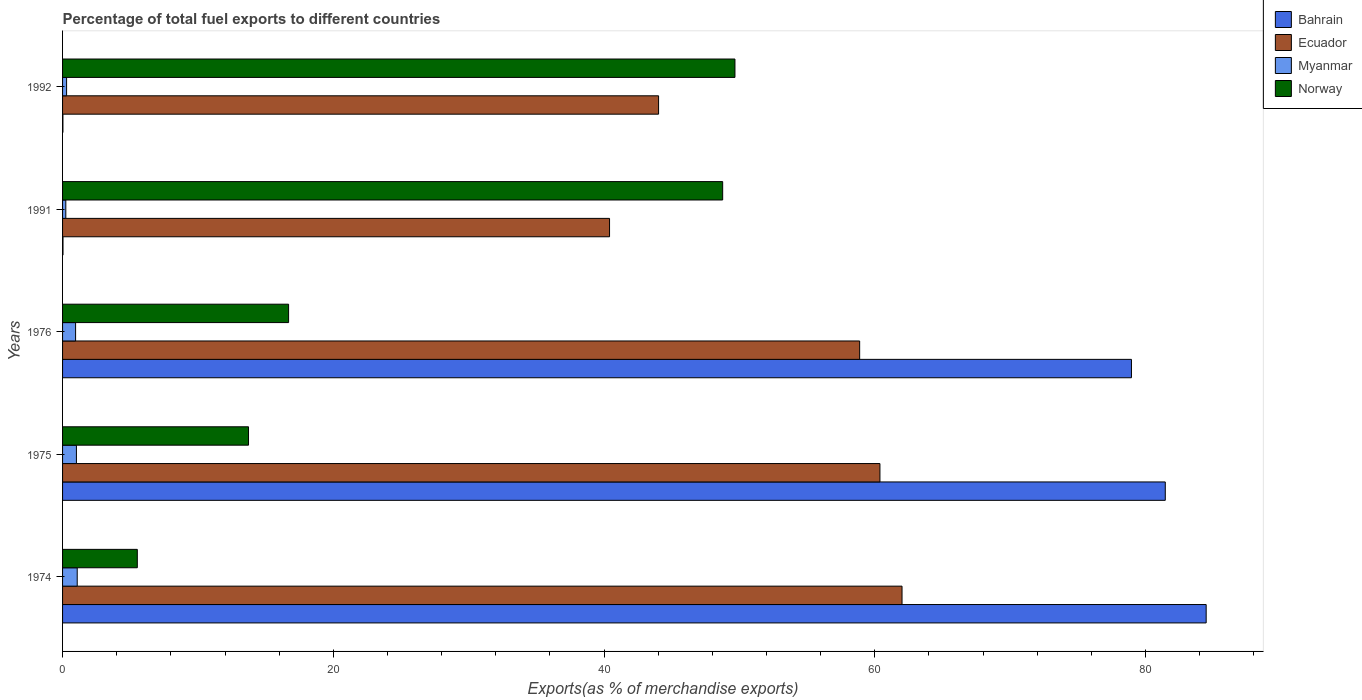How many different coloured bars are there?
Offer a very short reply. 4. How many groups of bars are there?
Provide a short and direct response. 5. Are the number of bars on each tick of the Y-axis equal?
Offer a terse response. Yes. How many bars are there on the 2nd tick from the top?
Offer a very short reply. 4. How many bars are there on the 4th tick from the bottom?
Ensure brevity in your answer.  4. In how many cases, is the number of bars for a given year not equal to the number of legend labels?
Keep it short and to the point. 0. What is the percentage of exports to different countries in Norway in 1992?
Give a very brief answer. 49.67. Across all years, what is the maximum percentage of exports to different countries in Bahrain?
Provide a succinct answer. 84.48. Across all years, what is the minimum percentage of exports to different countries in Ecuador?
Give a very brief answer. 40.41. In which year was the percentage of exports to different countries in Bahrain maximum?
Give a very brief answer. 1974. In which year was the percentage of exports to different countries in Norway minimum?
Keep it short and to the point. 1974. What is the total percentage of exports to different countries in Norway in the graph?
Your response must be concise. 134.38. What is the difference between the percentage of exports to different countries in Ecuador in 1975 and that in 1992?
Your response must be concise. 16.35. What is the difference between the percentage of exports to different countries in Myanmar in 1975 and the percentage of exports to different countries in Norway in 1974?
Give a very brief answer. -4.5. What is the average percentage of exports to different countries in Norway per year?
Ensure brevity in your answer.  26.88. In the year 1976, what is the difference between the percentage of exports to different countries in Norway and percentage of exports to different countries in Myanmar?
Give a very brief answer. 15.73. In how many years, is the percentage of exports to different countries in Ecuador greater than 24 %?
Ensure brevity in your answer.  5. What is the ratio of the percentage of exports to different countries in Myanmar in 1976 to that in 1992?
Ensure brevity in your answer.  3.24. Is the percentage of exports to different countries in Myanmar in 1975 less than that in 1991?
Your response must be concise. No. What is the difference between the highest and the second highest percentage of exports to different countries in Norway?
Your answer should be compact. 0.91. What is the difference between the highest and the lowest percentage of exports to different countries in Bahrain?
Your answer should be very brief. 84.45. In how many years, is the percentage of exports to different countries in Norway greater than the average percentage of exports to different countries in Norway taken over all years?
Offer a very short reply. 2. Is it the case that in every year, the sum of the percentage of exports to different countries in Bahrain and percentage of exports to different countries in Norway is greater than the sum of percentage of exports to different countries in Myanmar and percentage of exports to different countries in Ecuador?
Your answer should be very brief. Yes. What does the 2nd bar from the top in 1976 represents?
Provide a succinct answer. Myanmar. How many bars are there?
Ensure brevity in your answer.  20. How many years are there in the graph?
Your answer should be very brief. 5. Does the graph contain grids?
Ensure brevity in your answer.  No. What is the title of the graph?
Provide a short and direct response. Percentage of total fuel exports to different countries. Does "St. Martin (French part)" appear as one of the legend labels in the graph?
Your answer should be very brief. No. What is the label or title of the X-axis?
Provide a short and direct response. Exports(as % of merchandise exports). What is the Exports(as % of merchandise exports) of Bahrain in 1974?
Ensure brevity in your answer.  84.48. What is the Exports(as % of merchandise exports) of Ecuador in 1974?
Give a very brief answer. 62.01. What is the Exports(as % of merchandise exports) of Myanmar in 1974?
Your response must be concise. 1.08. What is the Exports(as % of merchandise exports) of Norway in 1974?
Your response must be concise. 5.52. What is the Exports(as % of merchandise exports) in Bahrain in 1975?
Your response must be concise. 81.46. What is the Exports(as % of merchandise exports) in Ecuador in 1975?
Offer a very short reply. 60.38. What is the Exports(as % of merchandise exports) of Myanmar in 1975?
Your answer should be compact. 1.02. What is the Exports(as % of merchandise exports) of Norway in 1975?
Your answer should be compact. 13.74. What is the Exports(as % of merchandise exports) in Bahrain in 1976?
Your answer should be compact. 78.96. What is the Exports(as % of merchandise exports) in Ecuador in 1976?
Give a very brief answer. 58.88. What is the Exports(as % of merchandise exports) in Myanmar in 1976?
Keep it short and to the point. 0.96. What is the Exports(as % of merchandise exports) in Norway in 1976?
Your answer should be compact. 16.7. What is the Exports(as % of merchandise exports) of Bahrain in 1991?
Offer a very short reply. 0.03. What is the Exports(as % of merchandise exports) in Ecuador in 1991?
Your answer should be very brief. 40.41. What is the Exports(as % of merchandise exports) in Myanmar in 1991?
Provide a succinct answer. 0.24. What is the Exports(as % of merchandise exports) in Norway in 1991?
Offer a very short reply. 48.76. What is the Exports(as % of merchandise exports) in Bahrain in 1992?
Offer a terse response. 0.03. What is the Exports(as % of merchandise exports) in Ecuador in 1992?
Give a very brief answer. 44.03. What is the Exports(as % of merchandise exports) in Myanmar in 1992?
Your response must be concise. 0.3. What is the Exports(as % of merchandise exports) in Norway in 1992?
Offer a very short reply. 49.67. Across all years, what is the maximum Exports(as % of merchandise exports) of Bahrain?
Provide a succinct answer. 84.48. Across all years, what is the maximum Exports(as % of merchandise exports) in Ecuador?
Make the answer very short. 62.01. Across all years, what is the maximum Exports(as % of merchandise exports) of Myanmar?
Give a very brief answer. 1.08. Across all years, what is the maximum Exports(as % of merchandise exports) of Norway?
Offer a terse response. 49.67. Across all years, what is the minimum Exports(as % of merchandise exports) of Bahrain?
Your answer should be compact. 0.03. Across all years, what is the minimum Exports(as % of merchandise exports) of Ecuador?
Ensure brevity in your answer.  40.41. Across all years, what is the minimum Exports(as % of merchandise exports) in Myanmar?
Provide a succinct answer. 0.24. Across all years, what is the minimum Exports(as % of merchandise exports) in Norway?
Offer a terse response. 5.52. What is the total Exports(as % of merchandise exports) of Bahrain in the graph?
Provide a short and direct response. 244.95. What is the total Exports(as % of merchandise exports) of Ecuador in the graph?
Ensure brevity in your answer.  265.7. What is the total Exports(as % of merchandise exports) of Myanmar in the graph?
Ensure brevity in your answer.  3.61. What is the total Exports(as % of merchandise exports) in Norway in the graph?
Offer a terse response. 134.38. What is the difference between the Exports(as % of merchandise exports) of Bahrain in 1974 and that in 1975?
Provide a succinct answer. 3.02. What is the difference between the Exports(as % of merchandise exports) in Ecuador in 1974 and that in 1975?
Keep it short and to the point. 1.63. What is the difference between the Exports(as % of merchandise exports) in Myanmar in 1974 and that in 1975?
Keep it short and to the point. 0.06. What is the difference between the Exports(as % of merchandise exports) of Norway in 1974 and that in 1975?
Your answer should be very brief. -8.21. What is the difference between the Exports(as % of merchandise exports) of Bahrain in 1974 and that in 1976?
Your answer should be compact. 5.52. What is the difference between the Exports(as % of merchandise exports) in Ecuador in 1974 and that in 1976?
Provide a succinct answer. 3.13. What is the difference between the Exports(as % of merchandise exports) of Myanmar in 1974 and that in 1976?
Your answer should be compact. 0.12. What is the difference between the Exports(as % of merchandise exports) in Norway in 1974 and that in 1976?
Give a very brief answer. -11.17. What is the difference between the Exports(as % of merchandise exports) in Bahrain in 1974 and that in 1991?
Offer a terse response. 84.44. What is the difference between the Exports(as % of merchandise exports) in Ecuador in 1974 and that in 1991?
Your answer should be compact. 21.61. What is the difference between the Exports(as % of merchandise exports) of Myanmar in 1974 and that in 1991?
Offer a very short reply. 0.84. What is the difference between the Exports(as % of merchandise exports) of Norway in 1974 and that in 1991?
Keep it short and to the point. -43.24. What is the difference between the Exports(as % of merchandise exports) of Bahrain in 1974 and that in 1992?
Offer a very short reply. 84.45. What is the difference between the Exports(as % of merchandise exports) in Ecuador in 1974 and that in 1992?
Make the answer very short. 17.98. What is the difference between the Exports(as % of merchandise exports) of Myanmar in 1974 and that in 1992?
Ensure brevity in your answer.  0.79. What is the difference between the Exports(as % of merchandise exports) of Norway in 1974 and that in 1992?
Provide a short and direct response. -44.15. What is the difference between the Exports(as % of merchandise exports) of Bahrain in 1975 and that in 1976?
Provide a short and direct response. 2.5. What is the difference between the Exports(as % of merchandise exports) of Ecuador in 1975 and that in 1976?
Provide a short and direct response. 1.5. What is the difference between the Exports(as % of merchandise exports) in Myanmar in 1975 and that in 1976?
Your response must be concise. 0.06. What is the difference between the Exports(as % of merchandise exports) of Norway in 1975 and that in 1976?
Make the answer very short. -2.96. What is the difference between the Exports(as % of merchandise exports) in Bahrain in 1975 and that in 1991?
Provide a succinct answer. 81.42. What is the difference between the Exports(as % of merchandise exports) of Ecuador in 1975 and that in 1991?
Your answer should be compact. 19.97. What is the difference between the Exports(as % of merchandise exports) of Myanmar in 1975 and that in 1991?
Ensure brevity in your answer.  0.78. What is the difference between the Exports(as % of merchandise exports) in Norway in 1975 and that in 1991?
Provide a short and direct response. -35.02. What is the difference between the Exports(as % of merchandise exports) in Bahrain in 1975 and that in 1992?
Your answer should be very brief. 81.43. What is the difference between the Exports(as % of merchandise exports) of Ecuador in 1975 and that in 1992?
Give a very brief answer. 16.35. What is the difference between the Exports(as % of merchandise exports) of Myanmar in 1975 and that in 1992?
Make the answer very short. 0.73. What is the difference between the Exports(as % of merchandise exports) of Norway in 1975 and that in 1992?
Make the answer very short. -35.93. What is the difference between the Exports(as % of merchandise exports) of Bahrain in 1976 and that in 1991?
Provide a short and direct response. 78.93. What is the difference between the Exports(as % of merchandise exports) in Ecuador in 1976 and that in 1991?
Keep it short and to the point. 18.47. What is the difference between the Exports(as % of merchandise exports) in Myanmar in 1976 and that in 1991?
Your response must be concise. 0.72. What is the difference between the Exports(as % of merchandise exports) of Norway in 1976 and that in 1991?
Provide a succinct answer. -32.06. What is the difference between the Exports(as % of merchandise exports) in Bahrain in 1976 and that in 1992?
Your answer should be compact. 78.93. What is the difference between the Exports(as % of merchandise exports) in Ecuador in 1976 and that in 1992?
Make the answer very short. 14.85. What is the difference between the Exports(as % of merchandise exports) in Myanmar in 1976 and that in 1992?
Provide a succinct answer. 0.67. What is the difference between the Exports(as % of merchandise exports) in Norway in 1976 and that in 1992?
Make the answer very short. -32.97. What is the difference between the Exports(as % of merchandise exports) in Bahrain in 1991 and that in 1992?
Your answer should be compact. 0.01. What is the difference between the Exports(as % of merchandise exports) of Ecuador in 1991 and that in 1992?
Your response must be concise. -3.62. What is the difference between the Exports(as % of merchandise exports) of Myanmar in 1991 and that in 1992?
Ensure brevity in your answer.  -0.06. What is the difference between the Exports(as % of merchandise exports) in Norway in 1991 and that in 1992?
Your answer should be very brief. -0.91. What is the difference between the Exports(as % of merchandise exports) of Bahrain in 1974 and the Exports(as % of merchandise exports) of Ecuador in 1975?
Give a very brief answer. 24.1. What is the difference between the Exports(as % of merchandise exports) in Bahrain in 1974 and the Exports(as % of merchandise exports) in Myanmar in 1975?
Provide a short and direct response. 83.45. What is the difference between the Exports(as % of merchandise exports) of Bahrain in 1974 and the Exports(as % of merchandise exports) of Norway in 1975?
Keep it short and to the point. 70.74. What is the difference between the Exports(as % of merchandise exports) in Ecuador in 1974 and the Exports(as % of merchandise exports) in Myanmar in 1975?
Give a very brief answer. 60.99. What is the difference between the Exports(as % of merchandise exports) in Ecuador in 1974 and the Exports(as % of merchandise exports) in Norway in 1975?
Ensure brevity in your answer.  48.27. What is the difference between the Exports(as % of merchandise exports) of Myanmar in 1974 and the Exports(as % of merchandise exports) of Norway in 1975?
Offer a very short reply. -12.65. What is the difference between the Exports(as % of merchandise exports) in Bahrain in 1974 and the Exports(as % of merchandise exports) in Ecuador in 1976?
Offer a very short reply. 25.6. What is the difference between the Exports(as % of merchandise exports) in Bahrain in 1974 and the Exports(as % of merchandise exports) in Myanmar in 1976?
Give a very brief answer. 83.51. What is the difference between the Exports(as % of merchandise exports) in Bahrain in 1974 and the Exports(as % of merchandise exports) in Norway in 1976?
Keep it short and to the point. 67.78. What is the difference between the Exports(as % of merchandise exports) in Ecuador in 1974 and the Exports(as % of merchandise exports) in Myanmar in 1976?
Your answer should be compact. 61.05. What is the difference between the Exports(as % of merchandise exports) in Ecuador in 1974 and the Exports(as % of merchandise exports) in Norway in 1976?
Give a very brief answer. 45.31. What is the difference between the Exports(as % of merchandise exports) of Myanmar in 1974 and the Exports(as % of merchandise exports) of Norway in 1976?
Your answer should be compact. -15.61. What is the difference between the Exports(as % of merchandise exports) of Bahrain in 1974 and the Exports(as % of merchandise exports) of Ecuador in 1991?
Keep it short and to the point. 44.07. What is the difference between the Exports(as % of merchandise exports) in Bahrain in 1974 and the Exports(as % of merchandise exports) in Myanmar in 1991?
Keep it short and to the point. 84.24. What is the difference between the Exports(as % of merchandise exports) of Bahrain in 1974 and the Exports(as % of merchandise exports) of Norway in 1991?
Offer a terse response. 35.72. What is the difference between the Exports(as % of merchandise exports) in Ecuador in 1974 and the Exports(as % of merchandise exports) in Myanmar in 1991?
Make the answer very short. 61.77. What is the difference between the Exports(as % of merchandise exports) of Ecuador in 1974 and the Exports(as % of merchandise exports) of Norway in 1991?
Your answer should be compact. 13.25. What is the difference between the Exports(as % of merchandise exports) of Myanmar in 1974 and the Exports(as % of merchandise exports) of Norway in 1991?
Make the answer very short. -47.68. What is the difference between the Exports(as % of merchandise exports) in Bahrain in 1974 and the Exports(as % of merchandise exports) in Ecuador in 1992?
Provide a short and direct response. 40.45. What is the difference between the Exports(as % of merchandise exports) of Bahrain in 1974 and the Exports(as % of merchandise exports) of Myanmar in 1992?
Keep it short and to the point. 84.18. What is the difference between the Exports(as % of merchandise exports) in Bahrain in 1974 and the Exports(as % of merchandise exports) in Norway in 1992?
Provide a short and direct response. 34.81. What is the difference between the Exports(as % of merchandise exports) of Ecuador in 1974 and the Exports(as % of merchandise exports) of Myanmar in 1992?
Your answer should be very brief. 61.71. What is the difference between the Exports(as % of merchandise exports) of Ecuador in 1974 and the Exports(as % of merchandise exports) of Norway in 1992?
Your response must be concise. 12.34. What is the difference between the Exports(as % of merchandise exports) in Myanmar in 1974 and the Exports(as % of merchandise exports) in Norway in 1992?
Give a very brief answer. -48.59. What is the difference between the Exports(as % of merchandise exports) of Bahrain in 1975 and the Exports(as % of merchandise exports) of Ecuador in 1976?
Ensure brevity in your answer.  22.58. What is the difference between the Exports(as % of merchandise exports) in Bahrain in 1975 and the Exports(as % of merchandise exports) in Myanmar in 1976?
Make the answer very short. 80.49. What is the difference between the Exports(as % of merchandise exports) in Bahrain in 1975 and the Exports(as % of merchandise exports) in Norway in 1976?
Your response must be concise. 64.76. What is the difference between the Exports(as % of merchandise exports) in Ecuador in 1975 and the Exports(as % of merchandise exports) in Myanmar in 1976?
Your response must be concise. 59.41. What is the difference between the Exports(as % of merchandise exports) in Ecuador in 1975 and the Exports(as % of merchandise exports) in Norway in 1976?
Provide a succinct answer. 43.68. What is the difference between the Exports(as % of merchandise exports) of Myanmar in 1975 and the Exports(as % of merchandise exports) of Norway in 1976?
Keep it short and to the point. -15.67. What is the difference between the Exports(as % of merchandise exports) of Bahrain in 1975 and the Exports(as % of merchandise exports) of Ecuador in 1991?
Make the answer very short. 41.05. What is the difference between the Exports(as % of merchandise exports) of Bahrain in 1975 and the Exports(as % of merchandise exports) of Myanmar in 1991?
Give a very brief answer. 81.22. What is the difference between the Exports(as % of merchandise exports) in Bahrain in 1975 and the Exports(as % of merchandise exports) in Norway in 1991?
Make the answer very short. 32.7. What is the difference between the Exports(as % of merchandise exports) in Ecuador in 1975 and the Exports(as % of merchandise exports) in Myanmar in 1991?
Offer a very short reply. 60.14. What is the difference between the Exports(as % of merchandise exports) in Ecuador in 1975 and the Exports(as % of merchandise exports) in Norway in 1991?
Keep it short and to the point. 11.62. What is the difference between the Exports(as % of merchandise exports) in Myanmar in 1975 and the Exports(as % of merchandise exports) in Norway in 1991?
Your response must be concise. -47.74. What is the difference between the Exports(as % of merchandise exports) in Bahrain in 1975 and the Exports(as % of merchandise exports) in Ecuador in 1992?
Offer a very short reply. 37.43. What is the difference between the Exports(as % of merchandise exports) of Bahrain in 1975 and the Exports(as % of merchandise exports) of Myanmar in 1992?
Give a very brief answer. 81.16. What is the difference between the Exports(as % of merchandise exports) of Bahrain in 1975 and the Exports(as % of merchandise exports) of Norway in 1992?
Your answer should be very brief. 31.79. What is the difference between the Exports(as % of merchandise exports) in Ecuador in 1975 and the Exports(as % of merchandise exports) in Myanmar in 1992?
Your answer should be compact. 60.08. What is the difference between the Exports(as % of merchandise exports) of Ecuador in 1975 and the Exports(as % of merchandise exports) of Norway in 1992?
Give a very brief answer. 10.71. What is the difference between the Exports(as % of merchandise exports) in Myanmar in 1975 and the Exports(as % of merchandise exports) in Norway in 1992?
Offer a terse response. -48.65. What is the difference between the Exports(as % of merchandise exports) in Bahrain in 1976 and the Exports(as % of merchandise exports) in Ecuador in 1991?
Provide a short and direct response. 38.55. What is the difference between the Exports(as % of merchandise exports) of Bahrain in 1976 and the Exports(as % of merchandise exports) of Myanmar in 1991?
Your response must be concise. 78.72. What is the difference between the Exports(as % of merchandise exports) of Bahrain in 1976 and the Exports(as % of merchandise exports) of Norway in 1991?
Your response must be concise. 30.2. What is the difference between the Exports(as % of merchandise exports) of Ecuador in 1976 and the Exports(as % of merchandise exports) of Myanmar in 1991?
Ensure brevity in your answer.  58.64. What is the difference between the Exports(as % of merchandise exports) in Ecuador in 1976 and the Exports(as % of merchandise exports) in Norway in 1991?
Ensure brevity in your answer.  10.12. What is the difference between the Exports(as % of merchandise exports) of Myanmar in 1976 and the Exports(as % of merchandise exports) of Norway in 1991?
Your answer should be compact. -47.8. What is the difference between the Exports(as % of merchandise exports) of Bahrain in 1976 and the Exports(as % of merchandise exports) of Ecuador in 1992?
Keep it short and to the point. 34.93. What is the difference between the Exports(as % of merchandise exports) in Bahrain in 1976 and the Exports(as % of merchandise exports) in Myanmar in 1992?
Keep it short and to the point. 78.66. What is the difference between the Exports(as % of merchandise exports) of Bahrain in 1976 and the Exports(as % of merchandise exports) of Norway in 1992?
Keep it short and to the point. 29.29. What is the difference between the Exports(as % of merchandise exports) in Ecuador in 1976 and the Exports(as % of merchandise exports) in Myanmar in 1992?
Provide a short and direct response. 58.58. What is the difference between the Exports(as % of merchandise exports) in Ecuador in 1976 and the Exports(as % of merchandise exports) in Norway in 1992?
Provide a short and direct response. 9.21. What is the difference between the Exports(as % of merchandise exports) of Myanmar in 1976 and the Exports(as % of merchandise exports) of Norway in 1992?
Provide a short and direct response. -48.71. What is the difference between the Exports(as % of merchandise exports) in Bahrain in 1991 and the Exports(as % of merchandise exports) in Ecuador in 1992?
Offer a terse response. -44. What is the difference between the Exports(as % of merchandise exports) of Bahrain in 1991 and the Exports(as % of merchandise exports) of Myanmar in 1992?
Offer a very short reply. -0.27. What is the difference between the Exports(as % of merchandise exports) in Bahrain in 1991 and the Exports(as % of merchandise exports) in Norway in 1992?
Give a very brief answer. -49.64. What is the difference between the Exports(as % of merchandise exports) of Ecuador in 1991 and the Exports(as % of merchandise exports) of Myanmar in 1992?
Make the answer very short. 40.11. What is the difference between the Exports(as % of merchandise exports) in Ecuador in 1991 and the Exports(as % of merchandise exports) in Norway in 1992?
Offer a terse response. -9.26. What is the difference between the Exports(as % of merchandise exports) in Myanmar in 1991 and the Exports(as % of merchandise exports) in Norway in 1992?
Give a very brief answer. -49.43. What is the average Exports(as % of merchandise exports) of Bahrain per year?
Your response must be concise. 48.99. What is the average Exports(as % of merchandise exports) in Ecuador per year?
Provide a succinct answer. 53.14. What is the average Exports(as % of merchandise exports) of Myanmar per year?
Your response must be concise. 0.72. What is the average Exports(as % of merchandise exports) of Norway per year?
Your response must be concise. 26.88. In the year 1974, what is the difference between the Exports(as % of merchandise exports) of Bahrain and Exports(as % of merchandise exports) of Ecuador?
Offer a very short reply. 22.47. In the year 1974, what is the difference between the Exports(as % of merchandise exports) of Bahrain and Exports(as % of merchandise exports) of Myanmar?
Make the answer very short. 83.39. In the year 1974, what is the difference between the Exports(as % of merchandise exports) in Bahrain and Exports(as % of merchandise exports) in Norway?
Offer a terse response. 78.96. In the year 1974, what is the difference between the Exports(as % of merchandise exports) of Ecuador and Exports(as % of merchandise exports) of Myanmar?
Ensure brevity in your answer.  60.93. In the year 1974, what is the difference between the Exports(as % of merchandise exports) in Ecuador and Exports(as % of merchandise exports) in Norway?
Provide a short and direct response. 56.49. In the year 1974, what is the difference between the Exports(as % of merchandise exports) of Myanmar and Exports(as % of merchandise exports) of Norway?
Ensure brevity in your answer.  -4.44. In the year 1975, what is the difference between the Exports(as % of merchandise exports) of Bahrain and Exports(as % of merchandise exports) of Ecuador?
Keep it short and to the point. 21.08. In the year 1975, what is the difference between the Exports(as % of merchandise exports) in Bahrain and Exports(as % of merchandise exports) in Myanmar?
Offer a very short reply. 80.43. In the year 1975, what is the difference between the Exports(as % of merchandise exports) of Bahrain and Exports(as % of merchandise exports) of Norway?
Your response must be concise. 67.72. In the year 1975, what is the difference between the Exports(as % of merchandise exports) of Ecuador and Exports(as % of merchandise exports) of Myanmar?
Provide a short and direct response. 59.35. In the year 1975, what is the difference between the Exports(as % of merchandise exports) of Ecuador and Exports(as % of merchandise exports) of Norway?
Provide a succinct answer. 46.64. In the year 1975, what is the difference between the Exports(as % of merchandise exports) of Myanmar and Exports(as % of merchandise exports) of Norway?
Give a very brief answer. -12.71. In the year 1976, what is the difference between the Exports(as % of merchandise exports) of Bahrain and Exports(as % of merchandise exports) of Ecuador?
Your answer should be very brief. 20.08. In the year 1976, what is the difference between the Exports(as % of merchandise exports) in Bahrain and Exports(as % of merchandise exports) in Myanmar?
Your answer should be very brief. 78. In the year 1976, what is the difference between the Exports(as % of merchandise exports) of Bahrain and Exports(as % of merchandise exports) of Norway?
Your answer should be very brief. 62.26. In the year 1976, what is the difference between the Exports(as % of merchandise exports) in Ecuador and Exports(as % of merchandise exports) in Myanmar?
Offer a terse response. 57.92. In the year 1976, what is the difference between the Exports(as % of merchandise exports) of Ecuador and Exports(as % of merchandise exports) of Norway?
Provide a succinct answer. 42.18. In the year 1976, what is the difference between the Exports(as % of merchandise exports) in Myanmar and Exports(as % of merchandise exports) in Norway?
Your answer should be compact. -15.73. In the year 1991, what is the difference between the Exports(as % of merchandise exports) of Bahrain and Exports(as % of merchandise exports) of Ecuador?
Provide a short and direct response. -40.37. In the year 1991, what is the difference between the Exports(as % of merchandise exports) of Bahrain and Exports(as % of merchandise exports) of Myanmar?
Offer a terse response. -0.21. In the year 1991, what is the difference between the Exports(as % of merchandise exports) in Bahrain and Exports(as % of merchandise exports) in Norway?
Offer a terse response. -48.73. In the year 1991, what is the difference between the Exports(as % of merchandise exports) in Ecuador and Exports(as % of merchandise exports) in Myanmar?
Provide a short and direct response. 40.17. In the year 1991, what is the difference between the Exports(as % of merchandise exports) of Ecuador and Exports(as % of merchandise exports) of Norway?
Make the answer very short. -8.36. In the year 1991, what is the difference between the Exports(as % of merchandise exports) of Myanmar and Exports(as % of merchandise exports) of Norway?
Provide a short and direct response. -48.52. In the year 1992, what is the difference between the Exports(as % of merchandise exports) of Bahrain and Exports(as % of merchandise exports) of Ecuador?
Provide a succinct answer. -44. In the year 1992, what is the difference between the Exports(as % of merchandise exports) in Bahrain and Exports(as % of merchandise exports) in Myanmar?
Provide a short and direct response. -0.27. In the year 1992, what is the difference between the Exports(as % of merchandise exports) of Bahrain and Exports(as % of merchandise exports) of Norway?
Make the answer very short. -49.64. In the year 1992, what is the difference between the Exports(as % of merchandise exports) of Ecuador and Exports(as % of merchandise exports) of Myanmar?
Your response must be concise. 43.73. In the year 1992, what is the difference between the Exports(as % of merchandise exports) in Ecuador and Exports(as % of merchandise exports) in Norway?
Offer a terse response. -5.64. In the year 1992, what is the difference between the Exports(as % of merchandise exports) of Myanmar and Exports(as % of merchandise exports) of Norway?
Give a very brief answer. -49.37. What is the ratio of the Exports(as % of merchandise exports) of Bahrain in 1974 to that in 1975?
Your response must be concise. 1.04. What is the ratio of the Exports(as % of merchandise exports) of Ecuador in 1974 to that in 1975?
Keep it short and to the point. 1.03. What is the ratio of the Exports(as % of merchandise exports) of Myanmar in 1974 to that in 1975?
Your answer should be compact. 1.06. What is the ratio of the Exports(as % of merchandise exports) in Norway in 1974 to that in 1975?
Your answer should be compact. 0.4. What is the ratio of the Exports(as % of merchandise exports) in Bahrain in 1974 to that in 1976?
Keep it short and to the point. 1.07. What is the ratio of the Exports(as % of merchandise exports) of Ecuador in 1974 to that in 1976?
Offer a terse response. 1.05. What is the ratio of the Exports(as % of merchandise exports) of Myanmar in 1974 to that in 1976?
Ensure brevity in your answer.  1.12. What is the ratio of the Exports(as % of merchandise exports) of Norway in 1974 to that in 1976?
Provide a short and direct response. 0.33. What is the ratio of the Exports(as % of merchandise exports) of Bahrain in 1974 to that in 1991?
Offer a very short reply. 2632.59. What is the ratio of the Exports(as % of merchandise exports) in Ecuador in 1974 to that in 1991?
Your answer should be compact. 1.53. What is the ratio of the Exports(as % of merchandise exports) of Myanmar in 1974 to that in 1991?
Make the answer very short. 4.51. What is the ratio of the Exports(as % of merchandise exports) of Norway in 1974 to that in 1991?
Your response must be concise. 0.11. What is the ratio of the Exports(as % of merchandise exports) of Bahrain in 1974 to that in 1992?
Ensure brevity in your answer.  3261.88. What is the ratio of the Exports(as % of merchandise exports) in Ecuador in 1974 to that in 1992?
Offer a terse response. 1.41. What is the ratio of the Exports(as % of merchandise exports) of Myanmar in 1974 to that in 1992?
Offer a terse response. 3.64. What is the ratio of the Exports(as % of merchandise exports) in Norway in 1974 to that in 1992?
Offer a terse response. 0.11. What is the ratio of the Exports(as % of merchandise exports) in Bahrain in 1975 to that in 1976?
Your response must be concise. 1.03. What is the ratio of the Exports(as % of merchandise exports) of Ecuador in 1975 to that in 1976?
Your answer should be very brief. 1.03. What is the ratio of the Exports(as % of merchandise exports) of Myanmar in 1975 to that in 1976?
Make the answer very short. 1.06. What is the ratio of the Exports(as % of merchandise exports) in Norway in 1975 to that in 1976?
Offer a very short reply. 0.82. What is the ratio of the Exports(as % of merchandise exports) in Bahrain in 1975 to that in 1991?
Your response must be concise. 2538.45. What is the ratio of the Exports(as % of merchandise exports) in Ecuador in 1975 to that in 1991?
Keep it short and to the point. 1.49. What is the ratio of the Exports(as % of merchandise exports) of Myanmar in 1975 to that in 1991?
Provide a short and direct response. 4.27. What is the ratio of the Exports(as % of merchandise exports) in Norway in 1975 to that in 1991?
Keep it short and to the point. 0.28. What is the ratio of the Exports(as % of merchandise exports) in Bahrain in 1975 to that in 1992?
Provide a short and direct response. 3145.24. What is the ratio of the Exports(as % of merchandise exports) of Ecuador in 1975 to that in 1992?
Your response must be concise. 1.37. What is the ratio of the Exports(as % of merchandise exports) of Myanmar in 1975 to that in 1992?
Your response must be concise. 3.45. What is the ratio of the Exports(as % of merchandise exports) of Norway in 1975 to that in 1992?
Give a very brief answer. 0.28. What is the ratio of the Exports(as % of merchandise exports) of Bahrain in 1976 to that in 1991?
Offer a terse response. 2460.6. What is the ratio of the Exports(as % of merchandise exports) in Ecuador in 1976 to that in 1991?
Make the answer very short. 1.46. What is the ratio of the Exports(as % of merchandise exports) in Myanmar in 1976 to that in 1991?
Your answer should be very brief. 4.01. What is the ratio of the Exports(as % of merchandise exports) of Norway in 1976 to that in 1991?
Offer a very short reply. 0.34. What is the ratio of the Exports(as % of merchandise exports) of Bahrain in 1976 to that in 1992?
Your response must be concise. 3048.78. What is the ratio of the Exports(as % of merchandise exports) in Ecuador in 1976 to that in 1992?
Offer a terse response. 1.34. What is the ratio of the Exports(as % of merchandise exports) of Myanmar in 1976 to that in 1992?
Your answer should be very brief. 3.24. What is the ratio of the Exports(as % of merchandise exports) in Norway in 1976 to that in 1992?
Provide a succinct answer. 0.34. What is the ratio of the Exports(as % of merchandise exports) in Bahrain in 1991 to that in 1992?
Your response must be concise. 1.24. What is the ratio of the Exports(as % of merchandise exports) in Ecuador in 1991 to that in 1992?
Give a very brief answer. 0.92. What is the ratio of the Exports(as % of merchandise exports) of Myanmar in 1991 to that in 1992?
Ensure brevity in your answer.  0.81. What is the ratio of the Exports(as % of merchandise exports) in Norway in 1991 to that in 1992?
Your answer should be very brief. 0.98. What is the difference between the highest and the second highest Exports(as % of merchandise exports) of Bahrain?
Provide a succinct answer. 3.02. What is the difference between the highest and the second highest Exports(as % of merchandise exports) in Ecuador?
Your response must be concise. 1.63. What is the difference between the highest and the second highest Exports(as % of merchandise exports) of Myanmar?
Ensure brevity in your answer.  0.06. What is the difference between the highest and the second highest Exports(as % of merchandise exports) in Norway?
Offer a very short reply. 0.91. What is the difference between the highest and the lowest Exports(as % of merchandise exports) in Bahrain?
Make the answer very short. 84.45. What is the difference between the highest and the lowest Exports(as % of merchandise exports) of Ecuador?
Provide a succinct answer. 21.61. What is the difference between the highest and the lowest Exports(as % of merchandise exports) in Myanmar?
Give a very brief answer. 0.84. What is the difference between the highest and the lowest Exports(as % of merchandise exports) in Norway?
Keep it short and to the point. 44.15. 